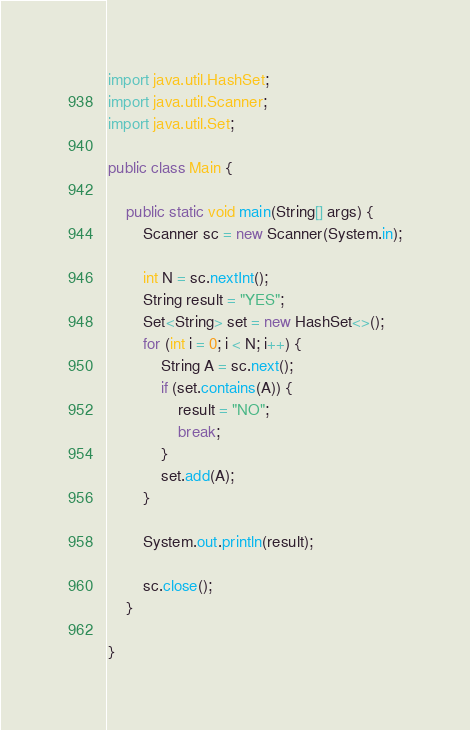Convert code to text. <code><loc_0><loc_0><loc_500><loc_500><_Java_>
import java.util.HashSet;
import java.util.Scanner;
import java.util.Set;

public class Main {

    public static void main(String[] args) {
        Scanner sc = new Scanner(System.in);

        int N = sc.nextInt();
        String result = "YES";
        Set<String> set = new HashSet<>();
        for (int i = 0; i < N; i++) {
            String A = sc.next();
            if (set.contains(A)) {
                result = "NO";
                break;
            }
            set.add(A);
        }

        System.out.println(result);

        sc.close();
    }

}
</code> 